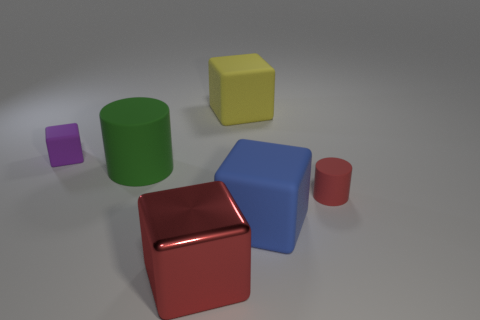Are there any other things that have the same color as the metal object?
Your response must be concise. Yes. Is the cube that is left of the big shiny thing made of the same material as the large red cube?
Offer a terse response. No. Are there an equal number of large blue blocks that are in front of the metallic thing and metallic blocks in front of the big blue thing?
Your answer should be very brief. No. There is a cylinder right of the cube that is behind the tiny purple matte object; how big is it?
Offer a terse response. Small. There is a big object that is behind the big blue cube and in front of the purple object; what material is it?
Offer a terse response. Rubber. What number of other objects are the same size as the yellow thing?
Your response must be concise. 3. The big metallic thing is what color?
Your response must be concise. Red. There is a cylinder that is in front of the green cylinder; is it the same color as the large cube to the left of the yellow block?
Give a very brief answer. Yes. What size is the red rubber thing?
Keep it short and to the point. Small. What is the size of the matte thing that is behind the tiny cube?
Provide a succinct answer. Large. 